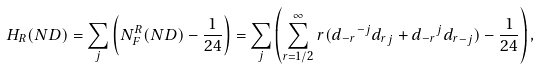<formula> <loc_0><loc_0><loc_500><loc_500>H _ { R } ( N D ) = \sum _ { j } \left ( N _ { F } ^ { R } ( N D ) - \frac { 1 } { 2 4 } \right ) = \sum _ { j } \left ( \sum _ { r = 1 / 2 } ^ { \infty } r ( { d _ { - r } } ^ { - j } { d _ { r } } _ { j } + { d _ { - r } } ^ { j } { d _ { r } } _ { - j } ) - \frac { 1 } { 2 4 } \right ) ,</formula> 